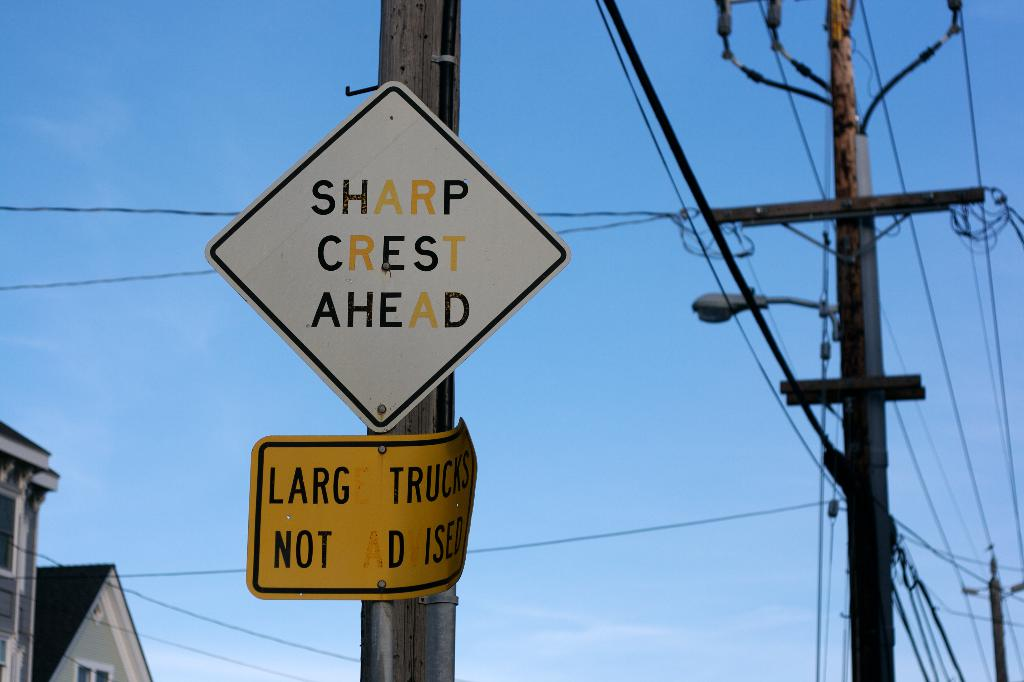Provide a one-sentence caption for the provided image.
Reference OCR token: SHARP, CREST, AHEAD, AD, LARG, TRUCKS, NOT, D, ISED Sharp crest ahead sign is on a pole. 